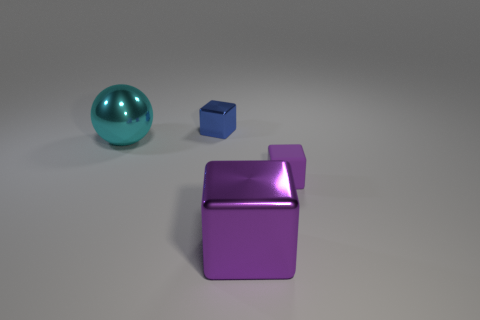Is there any other thing that is made of the same material as the small purple block?
Your response must be concise. No. How many objects are either tiny purple matte blocks or tiny blue shiny things?
Give a very brief answer. 2. What material is the object that is in front of the cyan metallic thing and left of the tiny purple rubber block?
Offer a terse response. Metal. Is the size of the cyan metal ball the same as the rubber block?
Your response must be concise. No. There is a metal cube in front of the large thing that is on the left side of the small blue block; what is its size?
Make the answer very short. Large. What number of metal objects are both right of the shiny ball and to the left of the purple shiny thing?
Your answer should be compact. 1. Is there a cyan metallic thing that is to the right of the small block on the left side of the large thing in front of the metallic sphere?
Your response must be concise. No. What shape is the metallic object that is the same size as the purple rubber block?
Provide a short and direct response. Cube. Are there any tiny matte blocks of the same color as the large metal sphere?
Provide a short and direct response. No. Do the tiny blue object and the rubber object have the same shape?
Your response must be concise. Yes. 